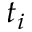<formula> <loc_0><loc_0><loc_500><loc_500>t _ { i }</formula> 